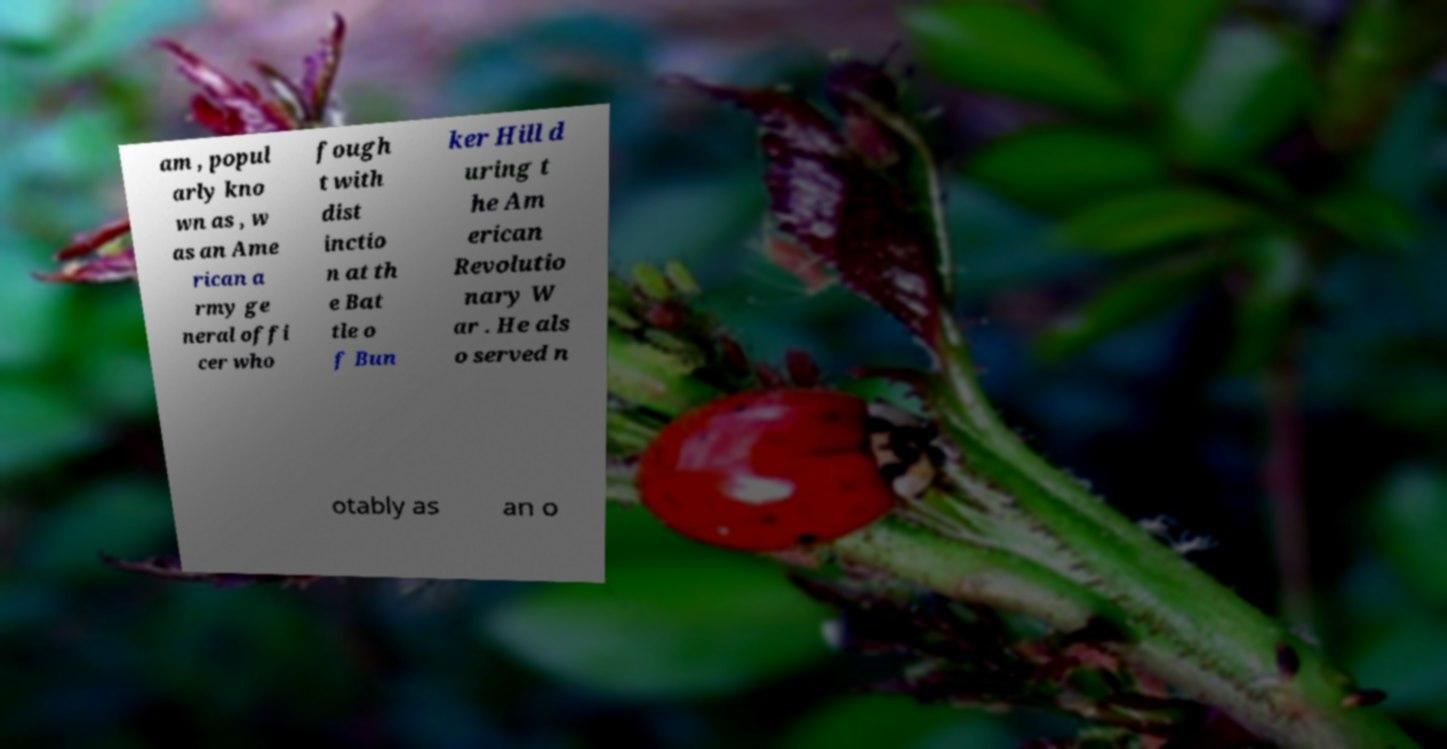Could you extract and type out the text from this image? am , popul arly kno wn as , w as an Ame rican a rmy ge neral offi cer who fough t with dist inctio n at th e Bat tle o f Bun ker Hill d uring t he Am erican Revolutio nary W ar . He als o served n otably as an o 